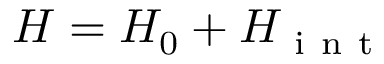Convert formula to latex. <formula><loc_0><loc_0><loc_500><loc_500>H = H _ { 0 } + H _ { i n t }</formula> 